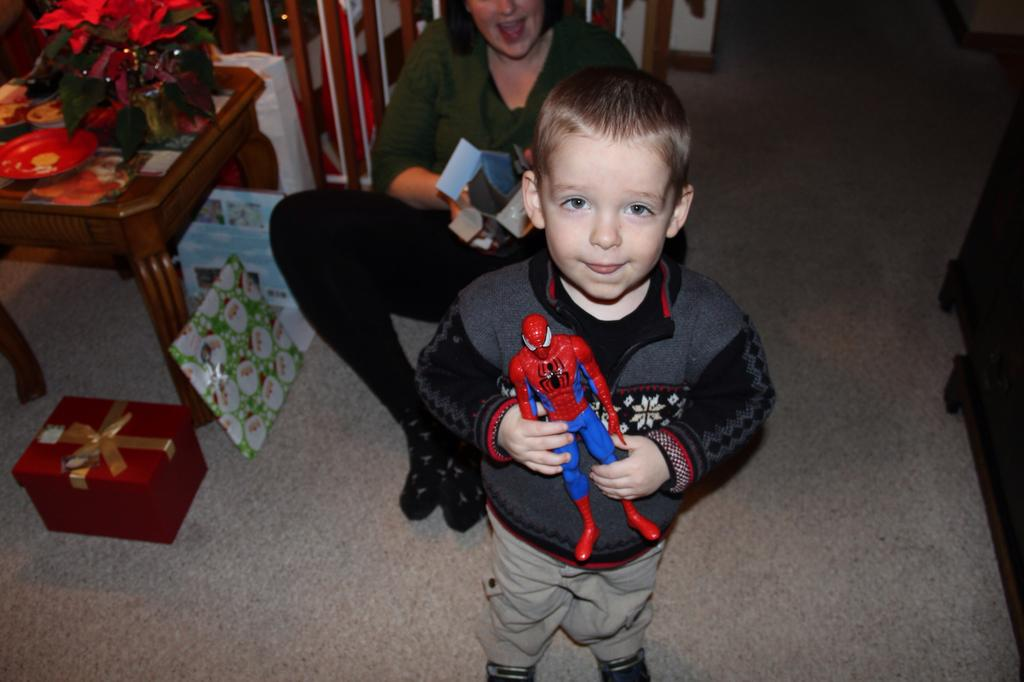Who is the main subject in the image? There is a boy in the image. What is the boy holding in the image? The boy is holding a Spider-Man toy. What is the woman in the image doing? The woman is seated on the floor in the image. What objects are related to gift-giving in the image? There are gift boxes in the image. What objects are related to serving or eating in the image? There are plates in the image. What is located on the table in the image? There is a flower vase on a table in the image. What type of drum can be heard playing in the background of the image? There is no drum or sound present in the image; it is a still photograph. 